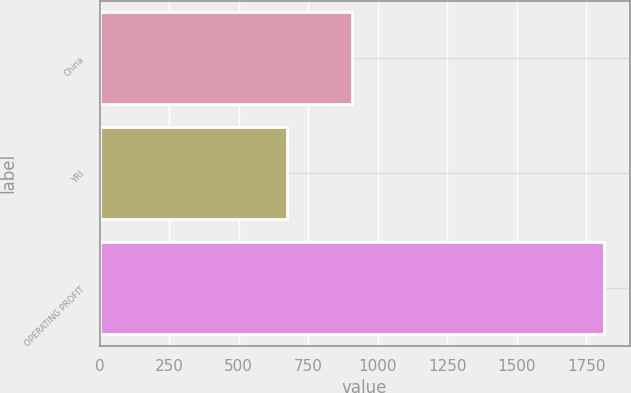Convert chart. <chart><loc_0><loc_0><loc_500><loc_500><bar_chart><fcel>China<fcel>YRI<fcel>OPERATING PROFIT<nl><fcel>908<fcel>673<fcel>1815<nl></chart> 